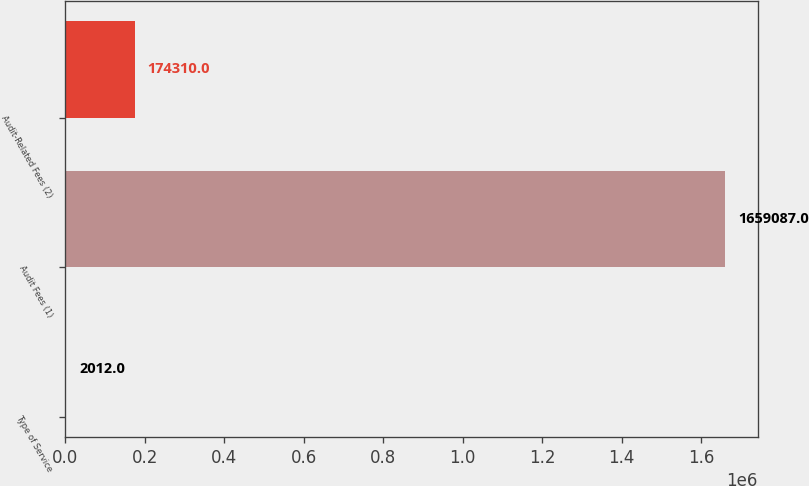Convert chart to OTSL. <chart><loc_0><loc_0><loc_500><loc_500><bar_chart><fcel>Type of Service<fcel>Audit Fees (1)<fcel>Audit-Related Fees (2)<nl><fcel>2012<fcel>1.65909e+06<fcel>174310<nl></chart> 